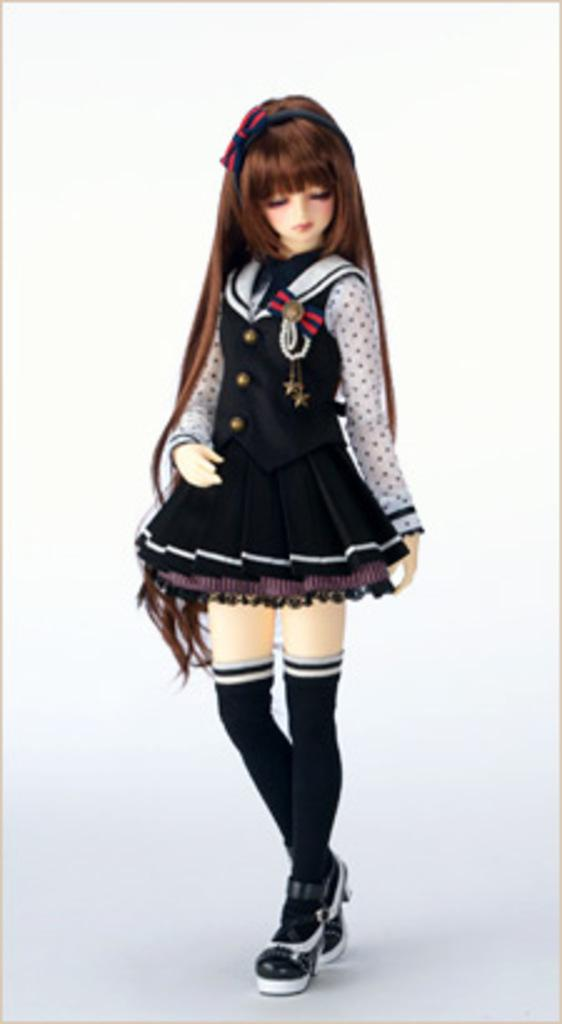What is the main subject of the image? The main subject of the image is a baby doll. Can you describe the appearance of the baby doll's hair? The baby doll has long hair. What type of clothing is the baby doll wearing? The baby doll is wearing a frock. What type of books can be found in the library depicted in the image? There is no library present in the image; it features a baby doll with long hair and a frock. How does the cat's purring affect the acoustics in the room shown in the image? There is no cat present in the image, and therefore no purring or impact on acoustics can be observed. 